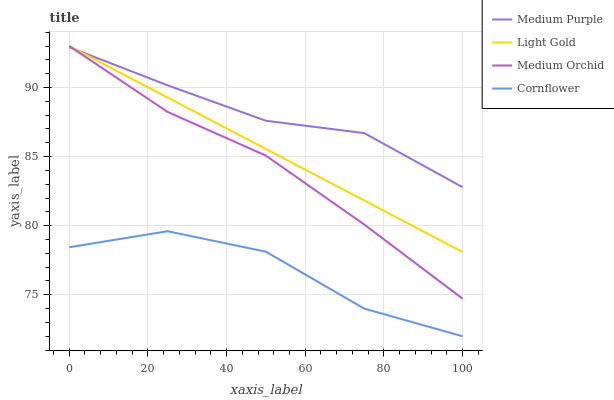Does Cornflower have the minimum area under the curve?
Answer yes or no. Yes. Does Medium Purple have the maximum area under the curve?
Answer yes or no. Yes. Does Medium Orchid have the minimum area under the curve?
Answer yes or no. No. Does Medium Orchid have the maximum area under the curve?
Answer yes or no. No. Is Light Gold the smoothest?
Answer yes or no. Yes. Is Cornflower the roughest?
Answer yes or no. Yes. Is Medium Orchid the smoothest?
Answer yes or no. No. Is Medium Orchid the roughest?
Answer yes or no. No. Does Cornflower have the lowest value?
Answer yes or no. Yes. Does Medium Orchid have the lowest value?
Answer yes or no. No. Does Light Gold have the highest value?
Answer yes or no. Yes. Does Cornflower have the highest value?
Answer yes or no. No. Is Cornflower less than Medium Orchid?
Answer yes or no. Yes. Is Medium Purple greater than Cornflower?
Answer yes or no. Yes. Does Medium Purple intersect Medium Orchid?
Answer yes or no. Yes. Is Medium Purple less than Medium Orchid?
Answer yes or no. No. Is Medium Purple greater than Medium Orchid?
Answer yes or no. No. Does Cornflower intersect Medium Orchid?
Answer yes or no. No. 